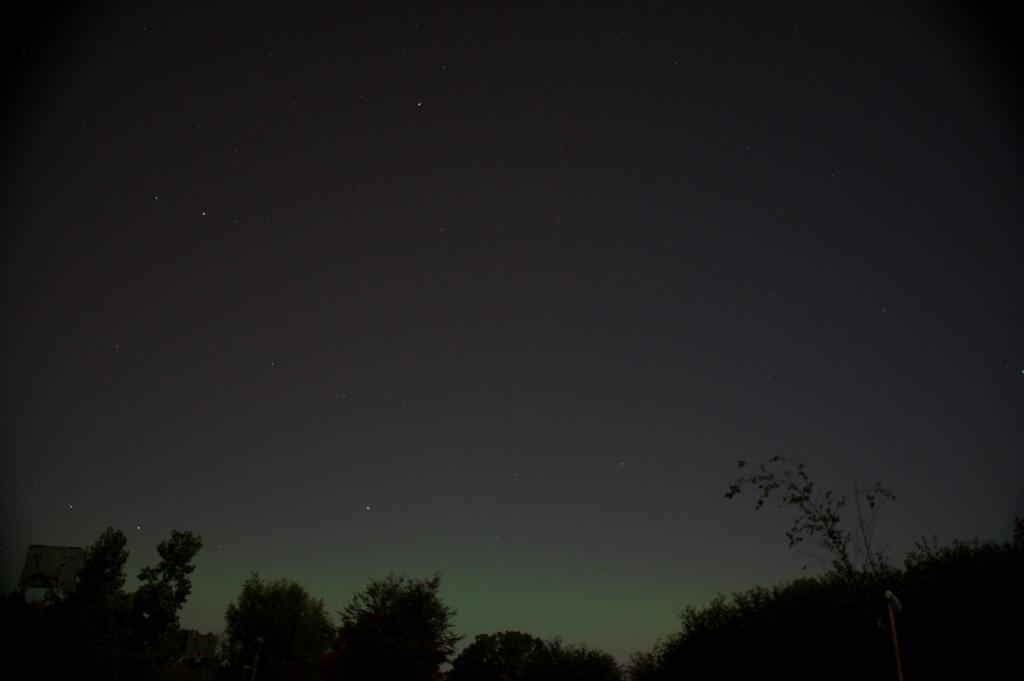What type of natural elements can be seen in the image? There are trees in the image. What else can be seen in the image besides the trees? There are some objects in the image. What part of the environment is visible in the image? The sky is visible in the image. Can you determine the time of day the image was taken? The image may have been taken during the night, as there is no mention of the sun or daylight. What type of vegetable is being harvested in the image? There is no vegetable or harvesting activity present in the image. How much corn can be seen in the image? There is no corn present in the image. 